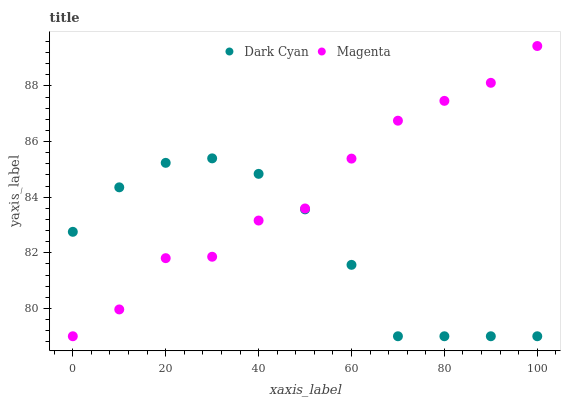Does Dark Cyan have the minimum area under the curve?
Answer yes or no. Yes. Does Magenta have the maximum area under the curve?
Answer yes or no. Yes. Does Magenta have the minimum area under the curve?
Answer yes or no. No. Is Dark Cyan the smoothest?
Answer yes or no. Yes. Is Magenta the roughest?
Answer yes or no. Yes. Is Magenta the smoothest?
Answer yes or no. No. Does Dark Cyan have the lowest value?
Answer yes or no. Yes. Does Magenta have the highest value?
Answer yes or no. Yes. Does Dark Cyan intersect Magenta?
Answer yes or no. Yes. Is Dark Cyan less than Magenta?
Answer yes or no. No. Is Dark Cyan greater than Magenta?
Answer yes or no. No. 